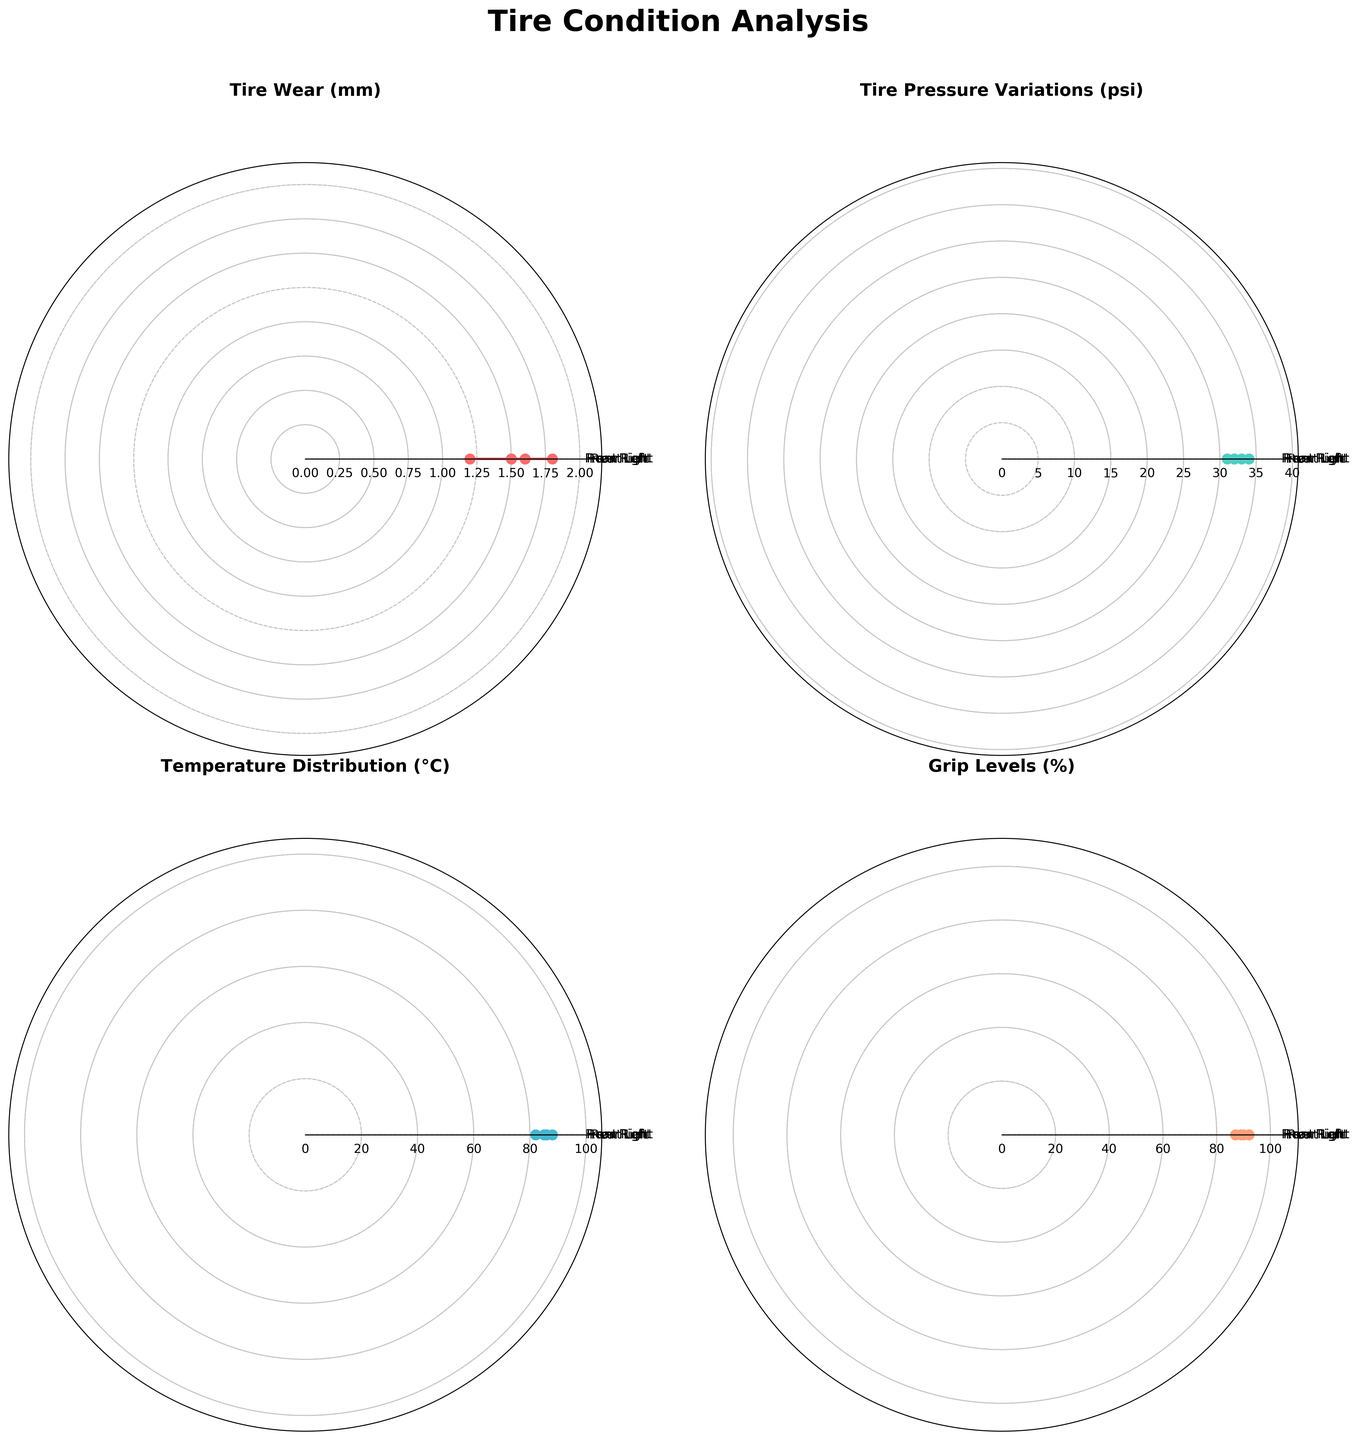What is the title of the figure? The title of the figure is displayed at the top and is written clearly.
Answer: Tire Condition Analysis How many subplots are in the figure? There are four distinct subplots, one for each tire condition (Tire Wear, Tire Pressure Variations, Temperature Distribution, Grip Levels).
Answer: 4 Which tire has the highest wear? By comparing the values on the "Tire Wear" subplot, the highest value is for the Rear Left tire.
Answer: Rear Left What is the average tire pressure? The tire pressures for all tires are 32, 31, 34, and 33 psi respectively. Summing these values (32 + 31 + 34 + 33 = 130) and dividing by the number of tires (4), we get the average tire pressure.
Answer: 32.5 psi Are the front tires balanced in terms of grip levels? Comparing the grip levels for the Front Left and Front Right tires in the "Grip Levels" subplot, the values are similar.
Answer: Yes Which tires have the most balanced wear? In the "Tire Wear" subplot, the values for the Front Left and Front Right tires are closest to each other.
Answer: Front Tires (Left and Right) What is the temperature difference between the Rear Left and Rear Right tires? The temperatures for the Rear Left and Rear Right tires in the "Temperature Distribution" subplot are 88°C and 86°C respectively. The difference is 88 - 86.
Answer: 2°C Which tire has the lowest grip level? By comparing the values on the "Grip Levels" subplot, the Rear Left tire has the lowest value.
Answer: Rear Left Which condition shows the greatest variation in values? Observing all the subplots, the "Temperature Distribution" subplot shows the greatest spread between its values.
Answer: Temperature Distribution 